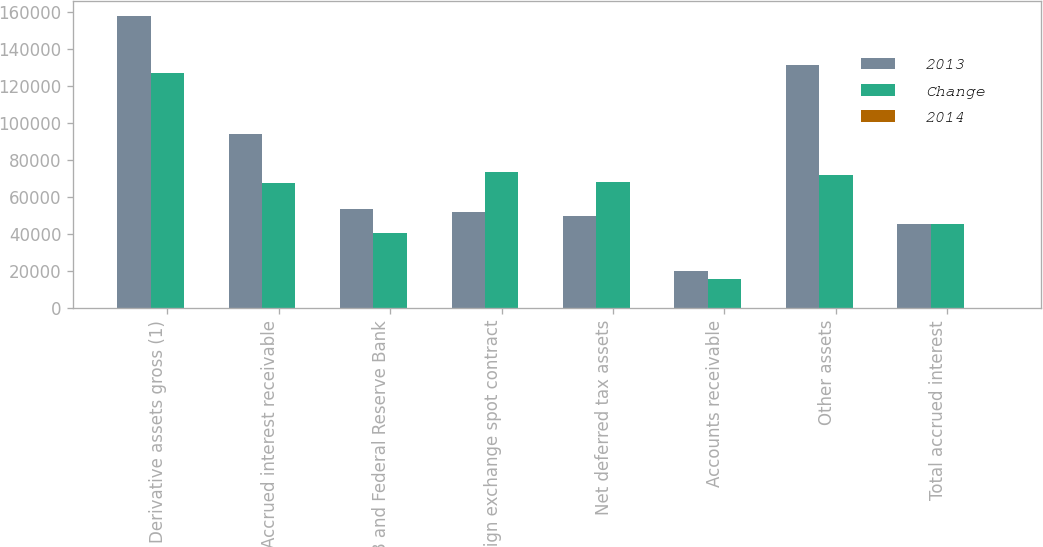Convert chart. <chart><loc_0><loc_0><loc_500><loc_500><stacked_bar_chart><ecel><fcel>Derivative assets gross (1)<fcel>Accrued interest receivable<fcel>FHLB and Federal Reserve Bank<fcel>Foreign exchange spot contract<fcel>Net deferred tax assets<fcel>Accounts receivable<fcel>Other assets<fcel>Total accrued interest<nl><fcel>2013<fcel>157990<fcel>94180<fcel>53496<fcel>51972<fcel>49921<fcel>20092<fcel>131580<fcel>45276.5<nl><fcel>Change<fcel>127114<fcel>67772<fcel>40632<fcel>73423<fcel>68237<fcel>15773<fcel>72159<fcel>45276.5<nl><fcel>2014<fcel>24.3<fcel>39<fcel>31.7<fcel>29.2<fcel>26.8<fcel>27.4<fcel>82.3<fcel>20.2<nl></chart> 